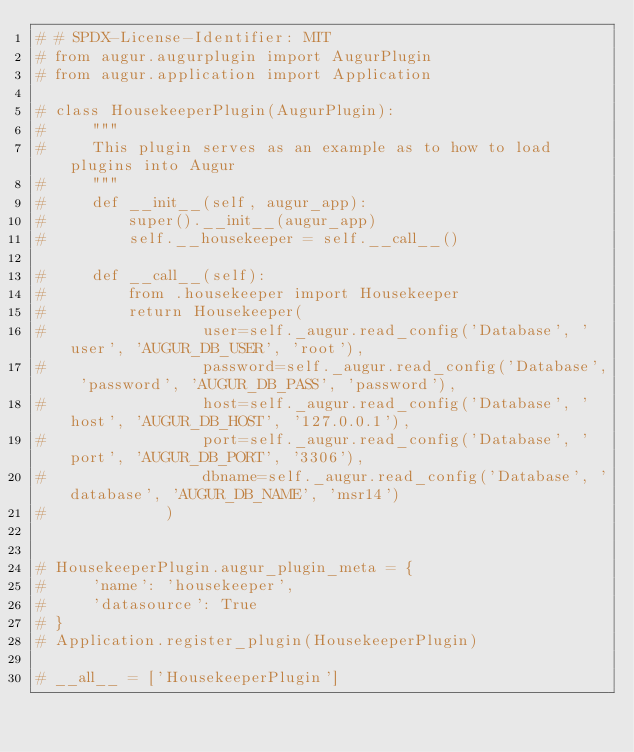<code> <loc_0><loc_0><loc_500><loc_500><_Python_># # SPDX-License-Identifier: MIT
# from augur.augurplugin import AugurPlugin
# from augur.application import Application

# class HousekeeperPlugin(AugurPlugin):
#     """
#     This plugin serves as an example as to how to load plugins into Augur
#     """
#     def __init__(self, augur_app):
#         super().__init__(augur_app)
#         self.__housekeeper = self.__call__()

#     def __call__(self):
#         from .housekeeper import Housekeeper
#         return Housekeeper(
#                 user=self._augur.read_config('Database', 'user', 'AUGUR_DB_USER', 'root'),
#                 password=self._augur.read_config('Database', 'password', 'AUGUR_DB_PASS', 'password'),
#                 host=self._augur.read_config('Database', 'host', 'AUGUR_DB_HOST', '127.0.0.1'),
#                 port=self._augur.read_config('Database', 'port', 'AUGUR_DB_PORT', '3306'),
#                 dbname=self._augur.read_config('Database', 'database', 'AUGUR_DB_NAME', 'msr14')
#             )


# HousekeeperPlugin.augur_plugin_meta = {
#     'name': 'housekeeper',
#     'datasource': True
# }
# Application.register_plugin(HousekeeperPlugin)

# __all__ = ['HousekeeperPlugin']</code> 